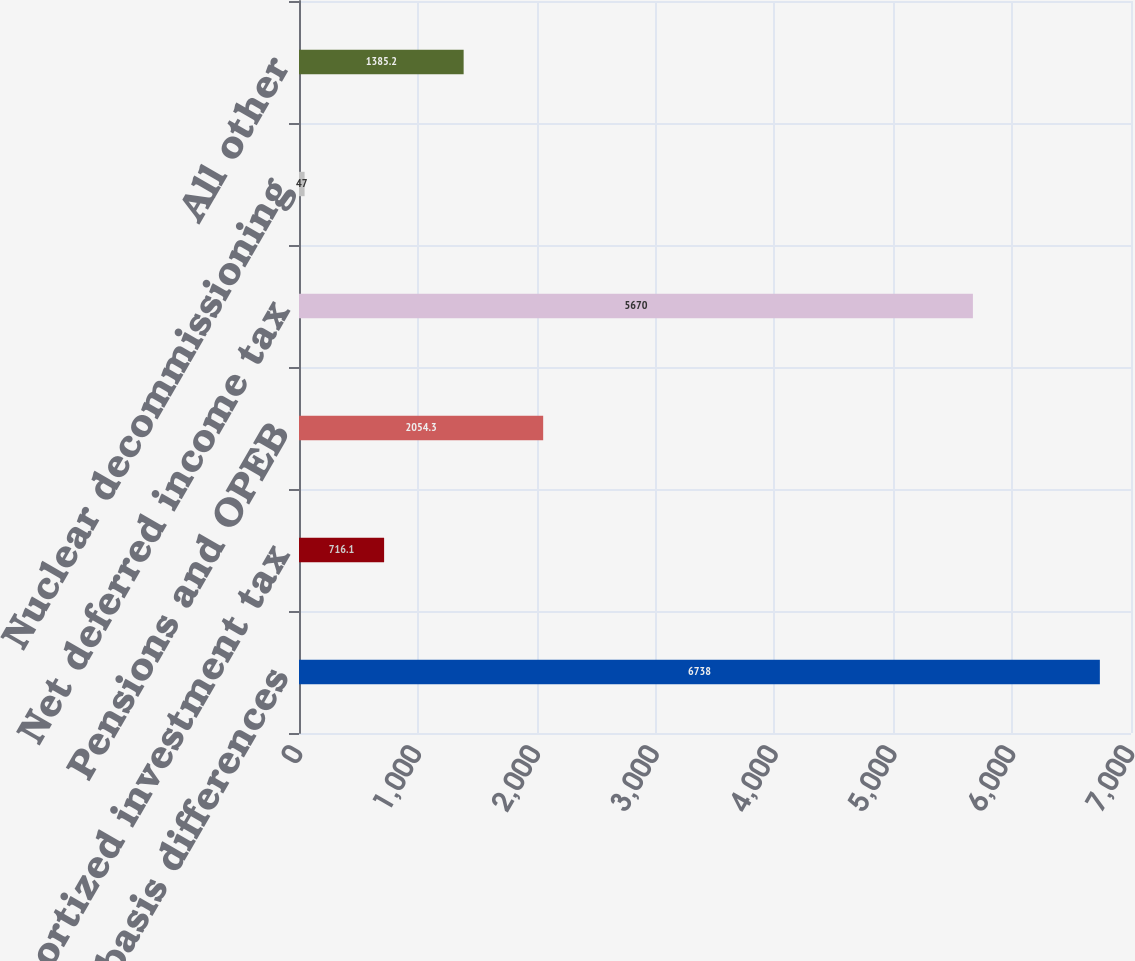Convert chart to OTSL. <chart><loc_0><loc_0><loc_500><loc_500><bar_chart><fcel>Property basis differences<fcel>Unamortized investment tax<fcel>Pensions and OPEB<fcel>Net deferred income tax<fcel>Nuclear decommissioning<fcel>All other<nl><fcel>6738<fcel>716.1<fcel>2054.3<fcel>5670<fcel>47<fcel>1385.2<nl></chart> 